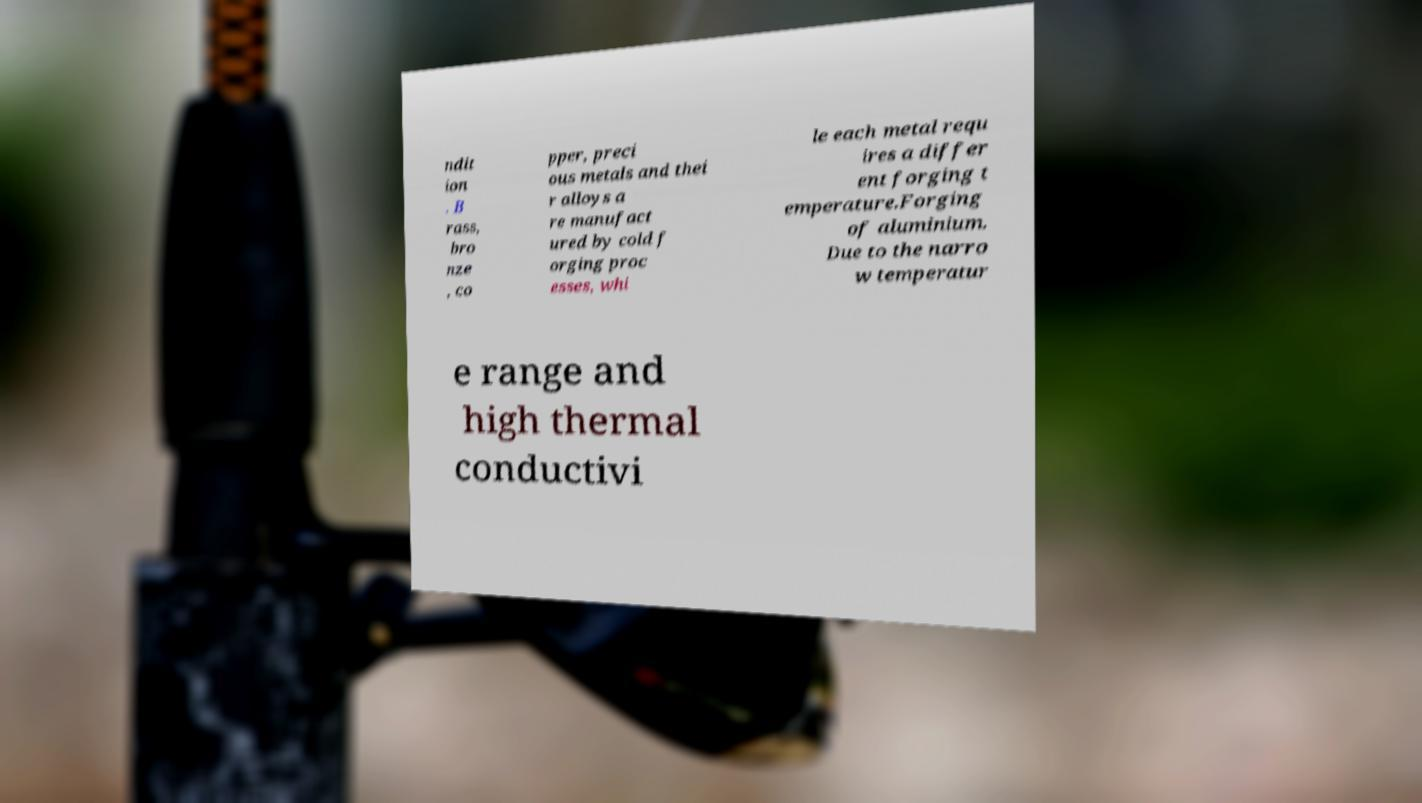Can you accurately transcribe the text from the provided image for me? ndit ion . B rass, bro nze , co pper, preci ous metals and thei r alloys a re manufact ured by cold f orging proc esses, whi le each metal requ ires a differ ent forging t emperature.Forging of aluminium. Due to the narro w temperatur e range and high thermal conductivi 